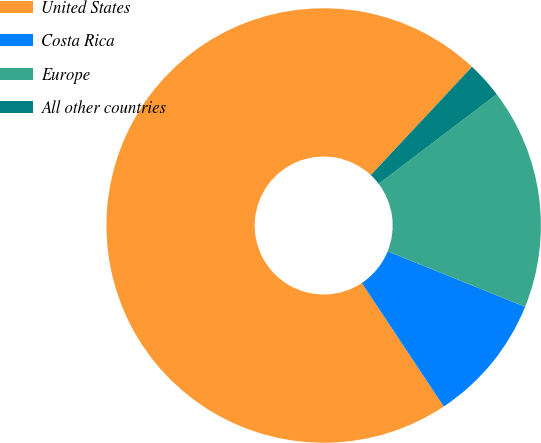Convert chart to OTSL. <chart><loc_0><loc_0><loc_500><loc_500><pie_chart><fcel>United States<fcel>Costa Rica<fcel>Europe<fcel>All other countries<nl><fcel>71.28%<fcel>9.57%<fcel>16.43%<fcel>2.71%<nl></chart> 